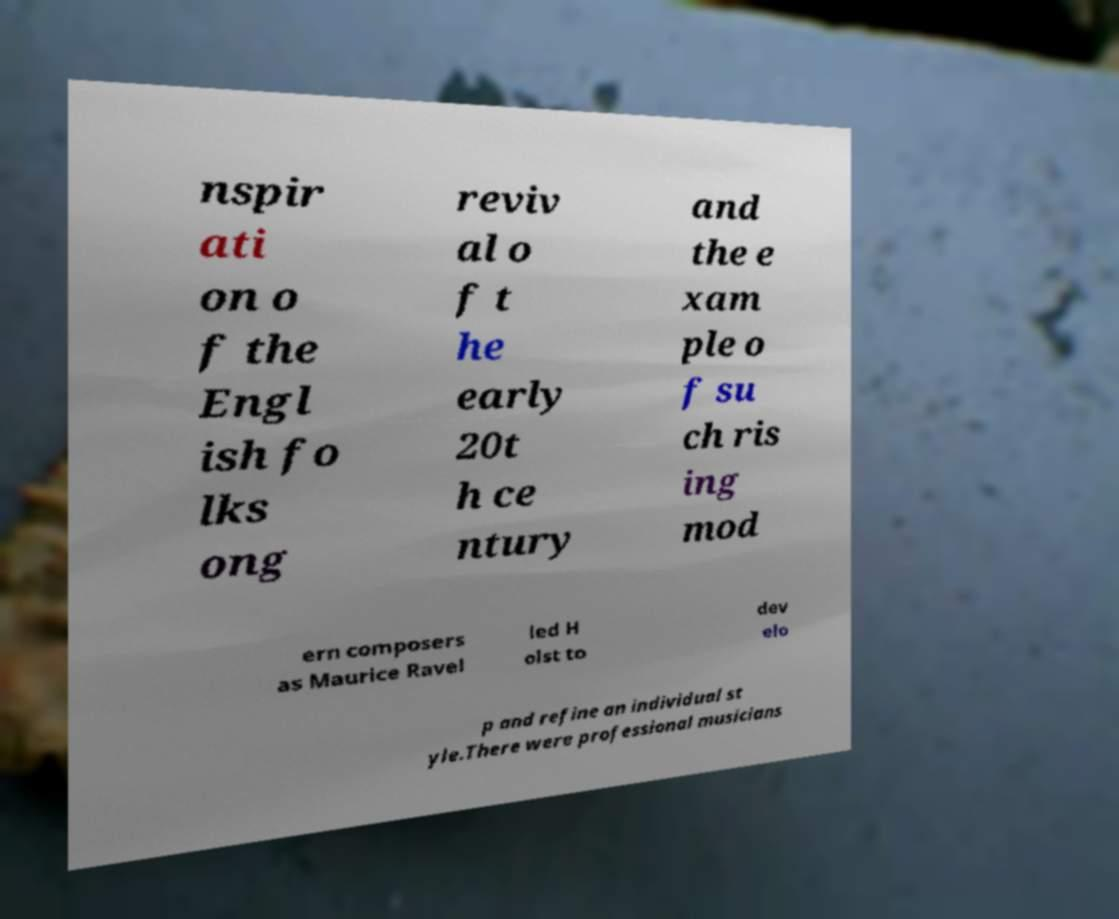Could you extract and type out the text from this image? nspir ati on o f the Engl ish fo lks ong reviv al o f t he early 20t h ce ntury and the e xam ple o f su ch ris ing mod ern composers as Maurice Ravel led H olst to dev elo p and refine an individual st yle.There were professional musicians 